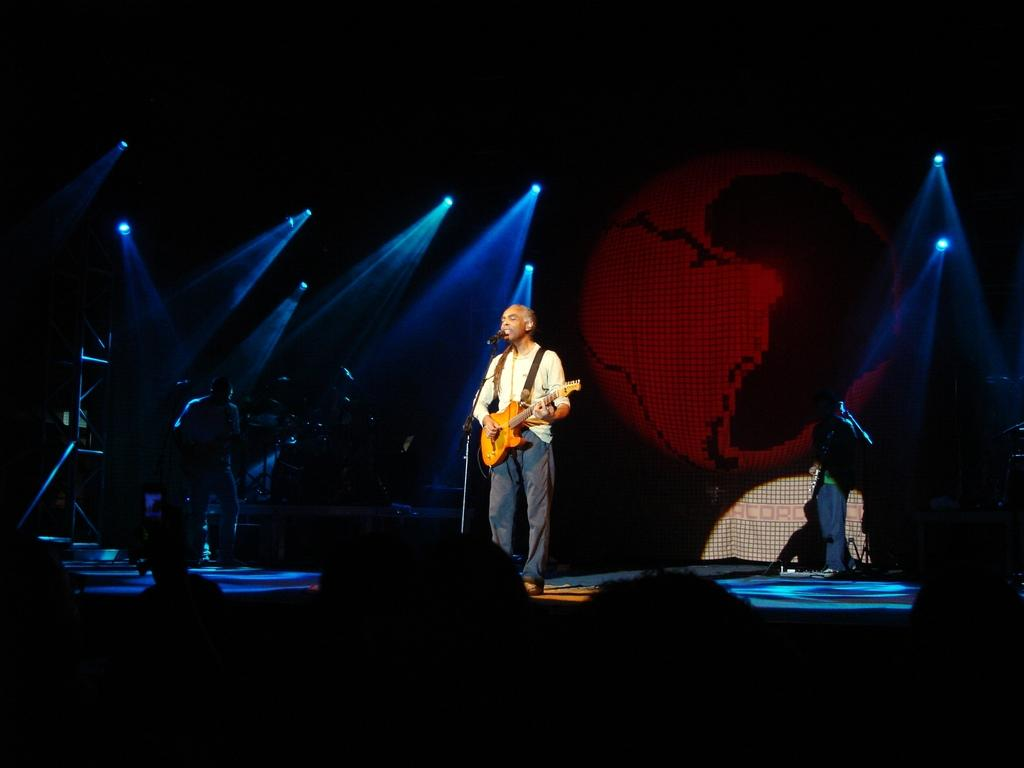What is the man doing on the stage in the image? The man is singing and playing a guitar on the stage. How is the man producing sound while singing? The man is using a microphone in front of him to amplify his voice. What instrument is the man playing? The man is playing a guitar. Can you describe the lighting in the image? There are lights visible in the background. What type of toothbrush is the man using while playing the guitar? There is no toothbrush present in the image; the man is playing a guitar and singing. What rule is the man following while performing on stage? The image does not provide information about any rules the man might be following while performing on stage. 